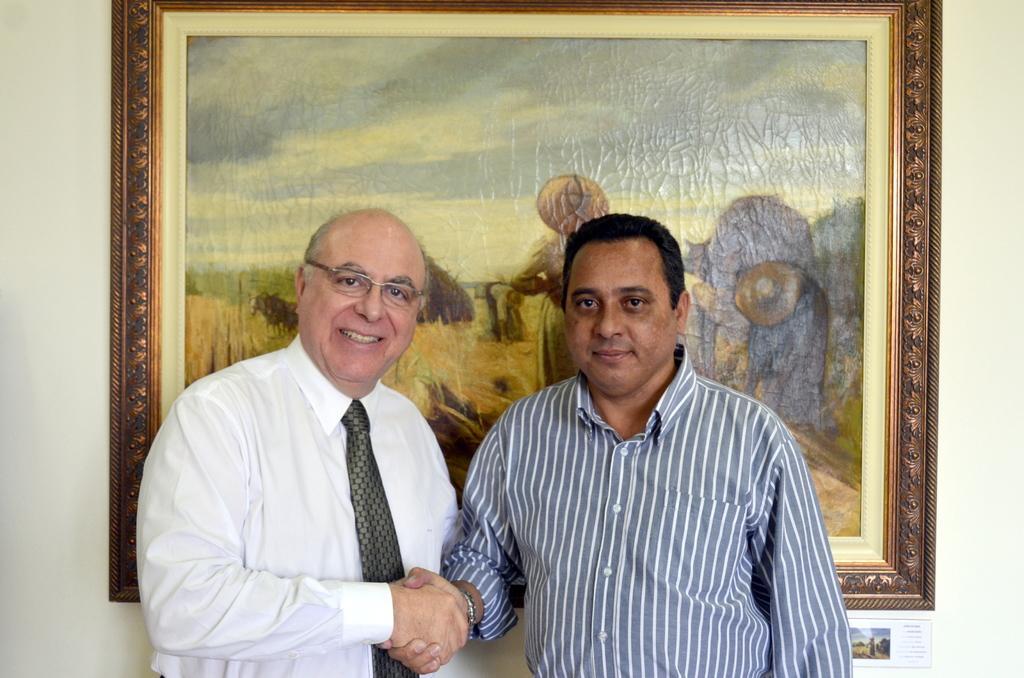Can you describe this image briefly? In this image there are two persons standing and shake hands, behind them there is a photo frame hanging on the wall. 